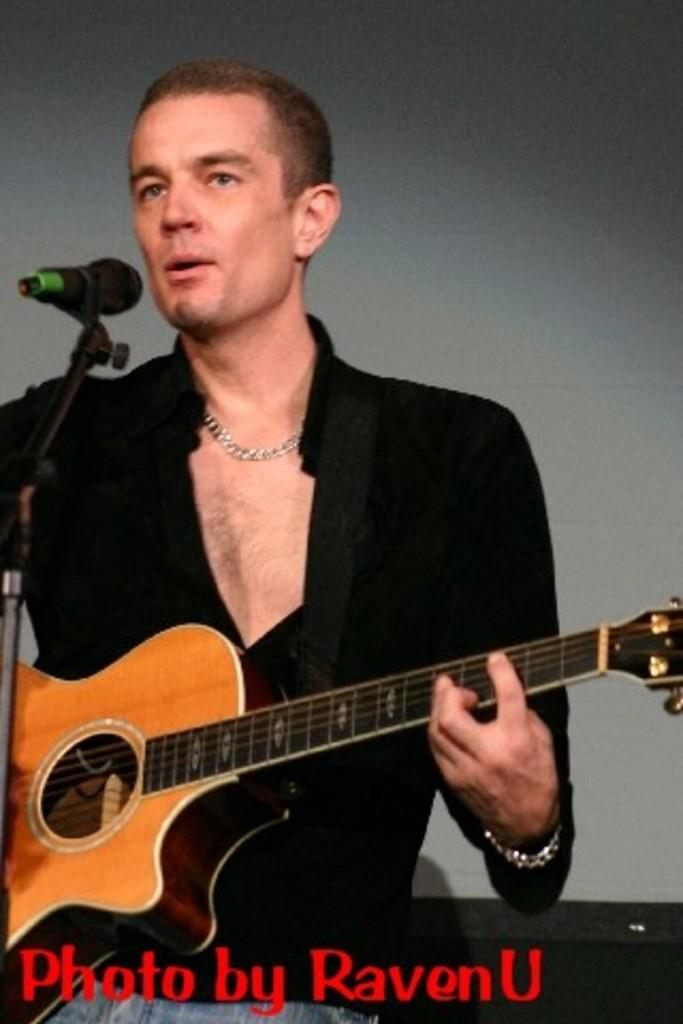Who is the main subject in the image? There is a man in the image. What is the man wearing? The man is wearing a black shirt. What is the man doing in front of the microphone? The man is singing and playing a guitar. What type of example can be seen in the image? There is no example present in the image; it features a man singing and playing a guitar. Can you tell me how many porters are visible in the image? There are no porters present in the image. 